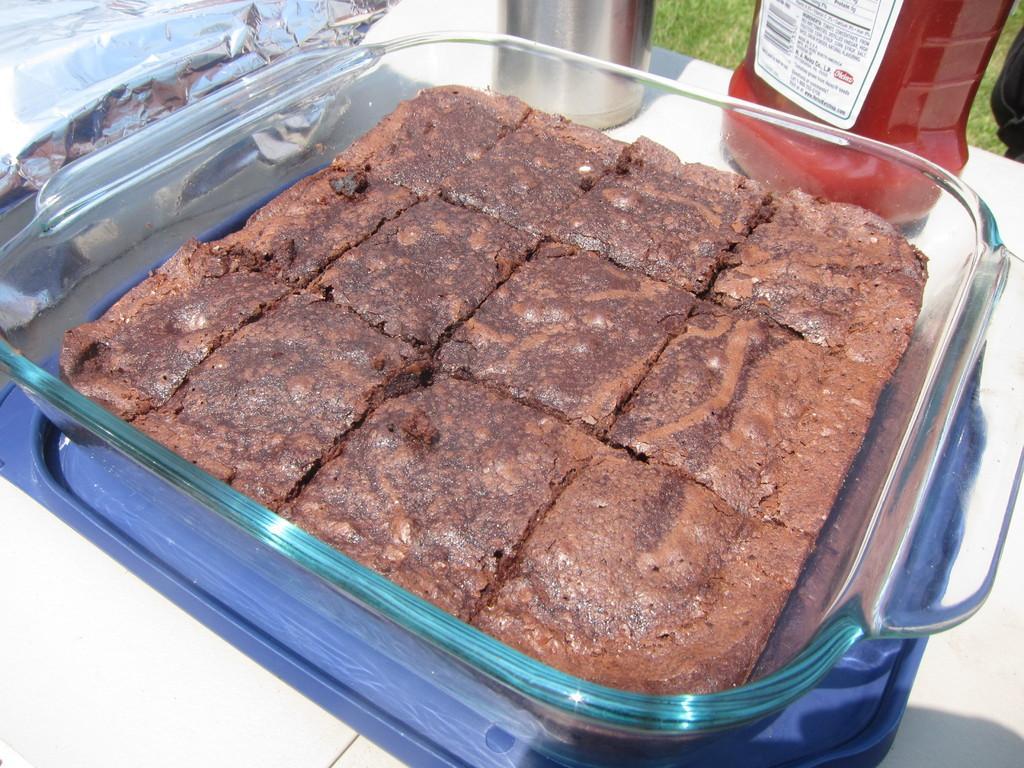In one or two sentences, can you explain what this image depicts? In the image we can see there is a chocolate cut into square pieces kept in the glass vessel and the glass vessel is kept on the table. There is a steel glass and red juice bottle kept on the table. 